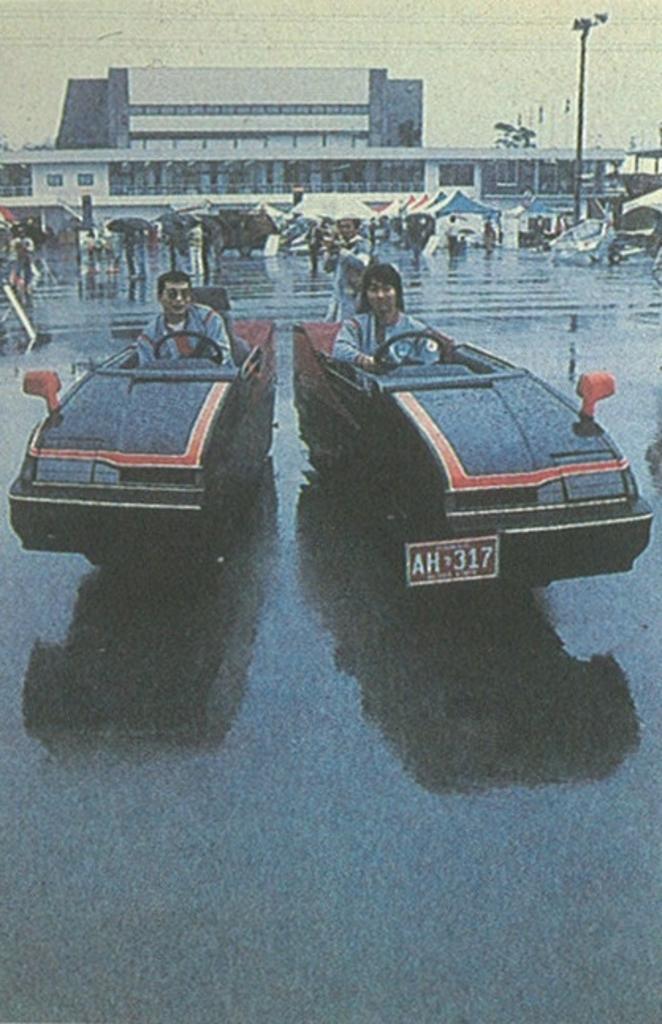Could you give a brief overview of what you see in this image? The picture is taken on the street. in the foreground of the picture there are two persons in the cars. In this picture there is road, the road is wet. In the middle of the picture there are tents, people carrying umbrellas, poles, building and other objects. At the top there are cables and sky. 